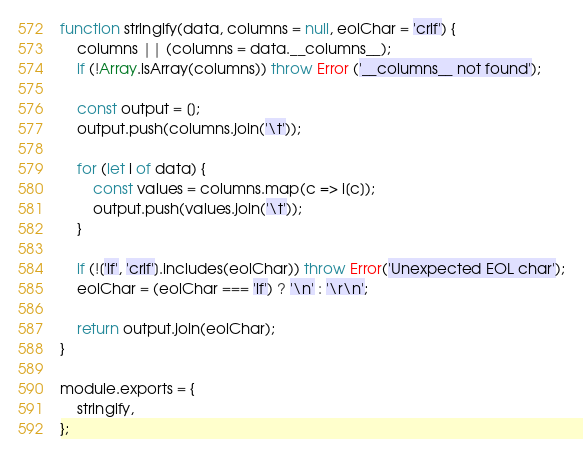<code> <loc_0><loc_0><loc_500><loc_500><_JavaScript_>
function stringify(data, columns = null, eolChar = 'crlf') {
    columns || (columns = data.__columns__);
    if (!Array.isArray(columns)) throw Error ('__columns__ not found');

    const output = [];
    output.push(columns.join('\t'));

    for (let i of data) {
        const values = columns.map(c => i[c]);
        output.push(values.join('\t'));
    }

    if (!['lf', 'crlf'].includes(eolChar)) throw Error('Unexpected EOL char');
    eolChar = (eolChar === 'lf') ? '\n' : '\r\n';

    return output.join(eolChar);
}

module.exports = {
    stringify,
};
</code> 